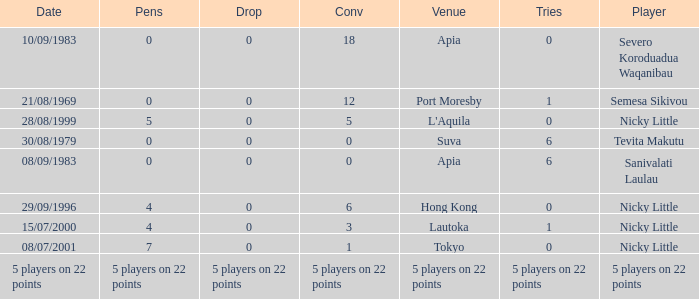Parse the table in full. {'header': ['Date', 'Pens', 'Drop', 'Conv', 'Venue', 'Tries', 'Player'], 'rows': [['10/09/1983', '0', '0', '18', 'Apia', '0', 'Severo Koroduadua Waqanibau'], ['21/08/1969', '0', '0', '12', 'Port Moresby', '1', 'Semesa Sikivou'], ['28/08/1999', '5', '0', '5', "L'Aquila", '0', 'Nicky Little'], ['30/08/1979', '0', '0', '0', 'Suva', '6', 'Tevita Makutu'], ['08/09/1983', '0', '0', '0', 'Apia', '6', 'Sanivalati Laulau'], ['29/09/1996', '4', '0', '6', 'Hong Kong', '0', 'Nicky Little'], ['15/07/2000', '4', '0', '3', 'Lautoka', '1', 'Nicky Little'], ['08/07/2001', '7', '0', '1', 'Tokyo', '0', 'Nicky Little'], ['5 players on 22 points', '5 players on 22 points', '5 players on 22 points', '5 players on 22 points', '5 players on 22 points', '5 players on 22 points', '5 players on 22 points']]} How many conversions did Severo Koroduadua Waqanibau have when he has 0 pens? 18.0. 